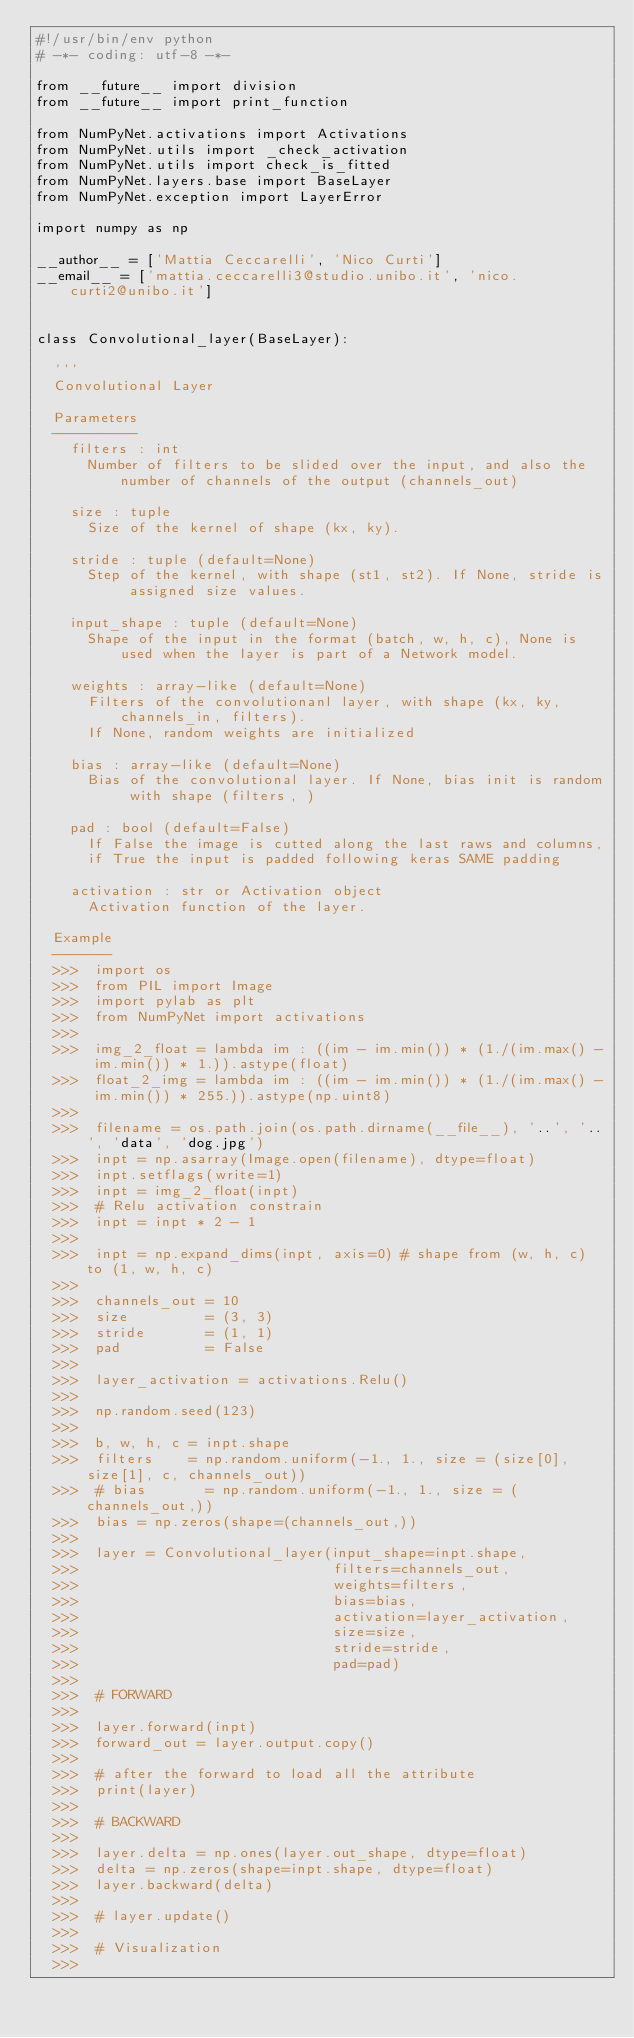Convert code to text. <code><loc_0><loc_0><loc_500><loc_500><_Python_>#!/usr/bin/env python
# -*- coding: utf-8 -*-

from __future__ import division
from __future__ import print_function

from NumPyNet.activations import Activations
from NumPyNet.utils import _check_activation
from NumPyNet.utils import check_is_fitted
from NumPyNet.layers.base import BaseLayer
from NumPyNet.exception import LayerError

import numpy as np

__author__ = ['Mattia Ceccarelli', 'Nico Curti']
__email__ = ['mattia.ceccarelli3@studio.unibo.it', 'nico.curti2@unibo.it']


class Convolutional_layer(BaseLayer):

  '''
  Convolutional Layer

  Parameters
  ----------
    filters : int
      Number of filters to be slided over the input, and also the number of channels of the output (channels_out)

    size : tuple
      Size of the kernel of shape (kx, ky).

    stride : tuple (default=None)
      Step of the kernel, with shape (st1, st2). If None, stride is assigned size values.

    input_shape : tuple (default=None)
      Shape of the input in the format (batch, w, h, c), None is used when the layer is part of a Network model.

    weights : array-like (default=None)
      Filters of the convolutionanl layer, with shape (kx, ky, channels_in, filters).
      If None, random weights are initialized

    bias : array-like (default=None)
      Bias of the convolutional layer. If None, bias init is random with shape (filters, )

    pad : bool (default=False)
      If False the image is cutted along the last raws and columns,
      if True the input is padded following keras SAME padding

    activation : str or Activation object
      Activation function of the layer.

  Example
  -------
  >>>  import os
  >>>  from PIL import Image
  >>>  import pylab as plt
  >>>  from NumPyNet import activations
  >>>
  >>>  img_2_float = lambda im : ((im - im.min()) * (1./(im.max() - im.min()) * 1.)).astype(float)
  >>>  float_2_img = lambda im : ((im - im.min()) * (1./(im.max() - im.min()) * 255.)).astype(np.uint8)
  >>>
  >>>  filename = os.path.join(os.path.dirname(__file__), '..', '..', 'data', 'dog.jpg')
  >>>  inpt = np.asarray(Image.open(filename), dtype=float)
  >>>  inpt.setflags(write=1)
  >>>  inpt = img_2_float(inpt)
  >>>  # Relu activation constrain
  >>>  inpt = inpt * 2 - 1
  >>>
  >>>  inpt = np.expand_dims(inpt, axis=0) # shape from (w, h, c) to (1, w, h, c)
  >>>
  >>>  channels_out = 10
  >>>  size         = (3, 3)
  >>>  stride       = (1, 1)
  >>>  pad          = False
  >>>
  >>>  layer_activation = activations.Relu()
  >>>
  >>>  np.random.seed(123)
  >>>
  >>>  b, w, h, c = inpt.shape
  >>>  filters    = np.random.uniform(-1., 1., size = (size[0], size[1], c, channels_out))
  >>>  # bias       = np.random.uniform(-1., 1., size = (channels_out,))
  >>>  bias = np.zeros(shape=(channels_out,))
  >>>
  >>>  layer = Convolutional_layer(input_shape=inpt.shape,
  >>>                              filters=channels_out,
  >>>                              weights=filters,
  >>>                              bias=bias,
  >>>                              activation=layer_activation,
  >>>                              size=size,
  >>>                              stride=stride,
  >>>                              pad=pad)
  >>>
  >>>  # FORWARD
  >>>
  >>>  layer.forward(inpt)
  >>>  forward_out = layer.output.copy()
  >>>
  >>>  # after the forward to load all the attribute
  >>>  print(layer)
  >>>
  >>>  # BACKWARD
  >>>
  >>>  layer.delta = np.ones(layer.out_shape, dtype=float)
  >>>  delta = np.zeros(shape=inpt.shape, dtype=float)
  >>>  layer.backward(delta)
  >>>
  >>>  # layer.update()
  >>>
  >>>  # Visualization
  >>></code> 